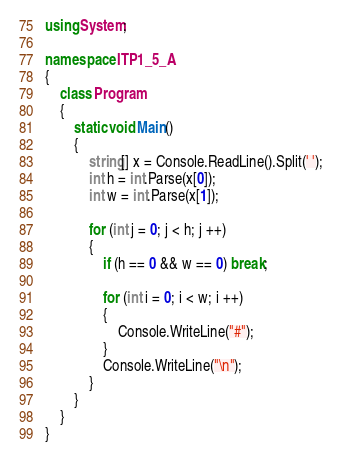Convert code to text. <code><loc_0><loc_0><loc_500><loc_500><_C#_>using System;

namespace ITP1_5_A
{
    class Program
    {
        static void Main()
        {
            string[] x = Console.ReadLine().Split(' ');
            int h = int.Parse(x[0]);
            int w = int.Parse(x[1]);
            
            for (int j = 0; j < h; j ++)
            {
                if (h == 0 && w == 0) break;
                
                for (int i = 0; i < w; i ++)
                {
                    Console.WriteLine("#");
                }
                Console.WriteLine("\n");
            }
        }
    }
}
</code> 